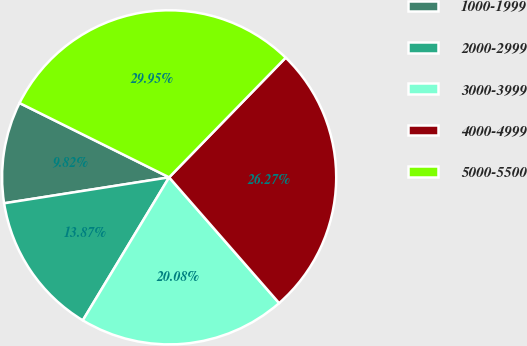<chart> <loc_0><loc_0><loc_500><loc_500><pie_chart><fcel>1000-1999<fcel>2000-2999<fcel>3000-3999<fcel>4000-4999<fcel>5000-5500<nl><fcel>9.82%<fcel>13.87%<fcel>20.08%<fcel>26.27%<fcel>29.95%<nl></chart> 